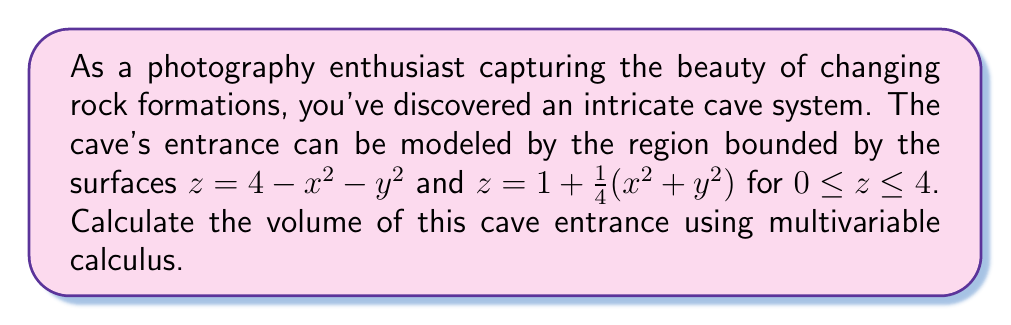Solve this math problem. To calculate the volume of the cave entrance, we need to set up a triple integral. The steps are as follows:

1) First, we need to determine the limits of integration. The bottom surface is given by $z = 1 + \frac{1}{4}(x^2 + y^2)$ and the top surface by $z = 4 - x^2 - y^2$.

2) The intersection of these surfaces occurs when:

   $4 - x^2 - y^2 = 1 + \frac{1}{4}(x^2 + y^2)$
   $3 = \frac{5}{4}(x^2 + y^2)$
   $x^2 + y^2 = \frac{12}{5}$

   This is the equation of a circle with radius $r = \sqrt{\frac{12}{5}}$.

3) We can use cylindrical coordinates for this problem. The volume integral in cylindrical coordinates is:

   $V = \int_0^{2\pi} \int_0^{\sqrt{\frac{12}{5}}} \int_{1 + \frac{1}{4}r^2}^{4 - r^2} r \, dz \, dr \, d\theta$

4) Let's solve the innermost integral first:

   $\int_{1 + \frac{1}{4}r^2}^{4 - r^2} dz = [z]_{1 + \frac{1}{4}r^2}^{4 - r^2} = (4 - r^2) - (1 + \frac{1}{4}r^2) = 3 - \frac{5}{4}r^2$

5) Now our integral becomes:

   $V = \int_0^{2\pi} \int_0^{\sqrt{\frac{12}{5}}} (3 - \frac{5}{4}r^2)r \, dr \, d\theta$

6) Integrate with respect to r:

   $\int_0^{\sqrt{\frac{12}{5}}} (3r - \frac{5}{4}r^3) \, dr = [\frac{3}{2}r^2 - \frac{5}{16}r^4]_0^{\sqrt{\frac{12}{5}}}$
   
   $= \frac{3}{2}(\frac{12}{5}) - \frac{5}{16}(\frac{12}{5})^2 - 0 = \frac{18}{5} - \frac{45}{20} = \frac{9}{5}$

7) Finally, integrate with respect to θ:

   $V = \int_0^{2\pi} \frac{9}{5} \, d\theta = \frac{9}{5}[θ]_0^{2\pi} = \frac{18\pi}{5}$

Thus, the volume of the cave entrance is $\frac{18\pi}{5}$ cubic units.
Answer: $\frac{18\pi}{5}$ cubic units 